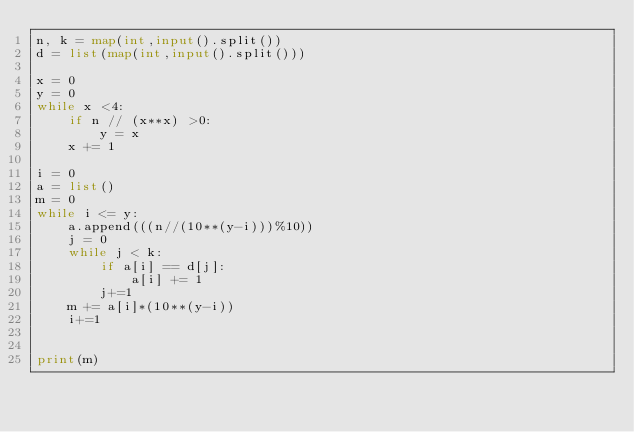Convert code to text. <code><loc_0><loc_0><loc_500><loc_500><_Python_>n, k = map(int,input().split())
d = list(map(int,input().split()))

x = 0
y = 0
while x <4:
    if n // (x**x) >0:
        y = x
    x += 1

i = 0
a = list()
m = 0
while i <= y:
    a.append(((n//(10**(y-i)))%10))
    j = 0
    while j < k:
        if a[i] == d[j]:
            a[i] += 1
        j+=1
    m += a[i]*(10**(y-i))
    i+=1


print(m)
</code> 